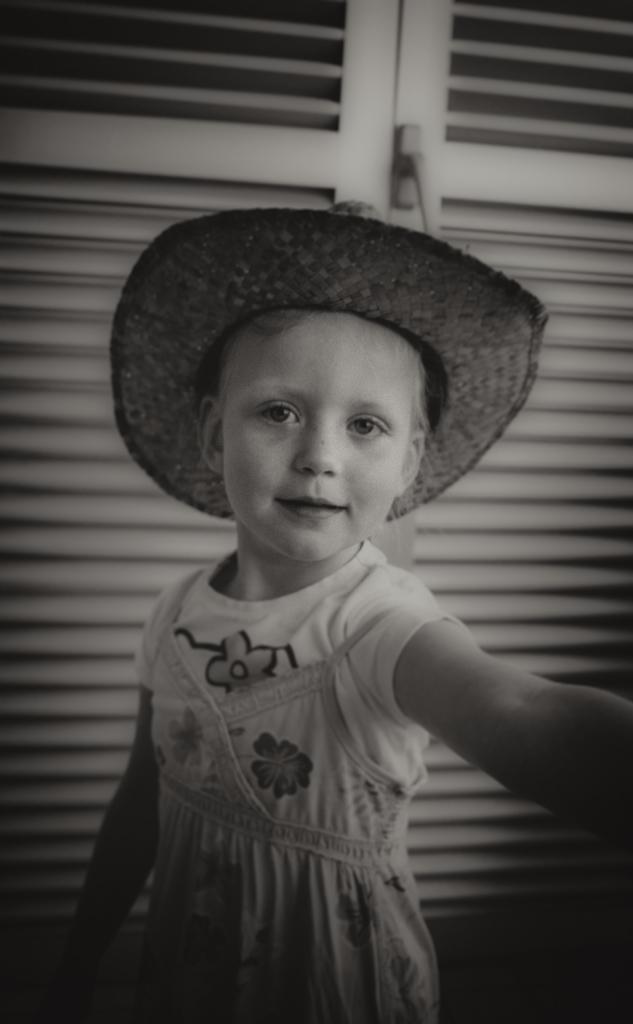Describe this image in one or two sentences. This is a black and white image, in it we can see a child wearing clothes and hat. This is a wood door. 